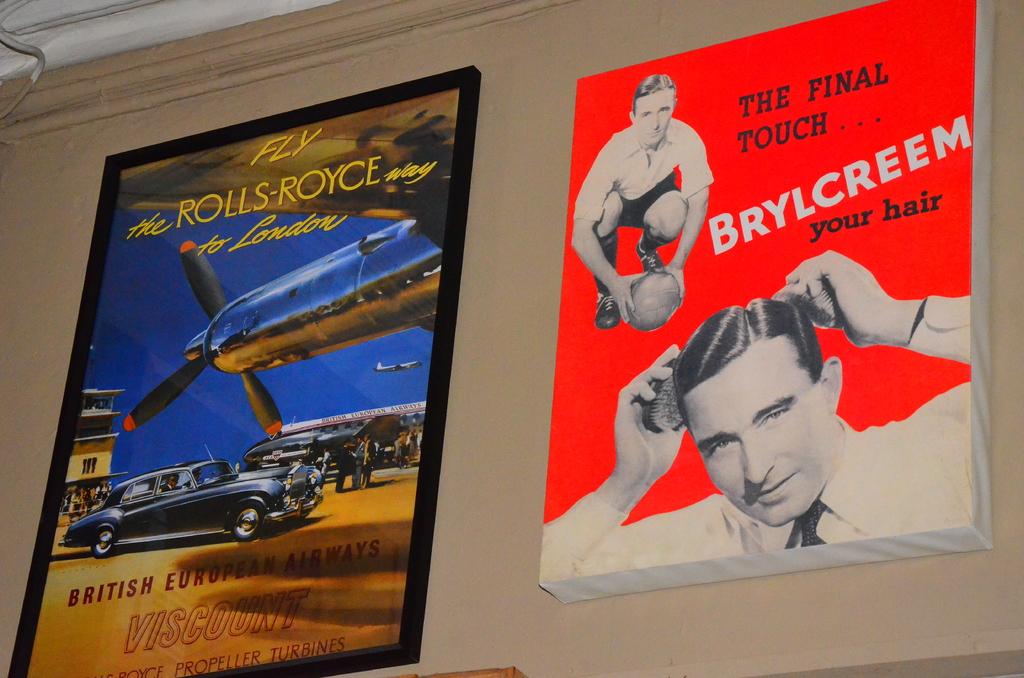What way should you fly to london?
Keep it short and to the point. The rolls-royce way. What should you put in your hair?
Give a very brief answer. Brylcreem. 